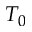<formula> <loc_0><loc_0><loc_500><loc_500>T _ { 0 }</formula> 